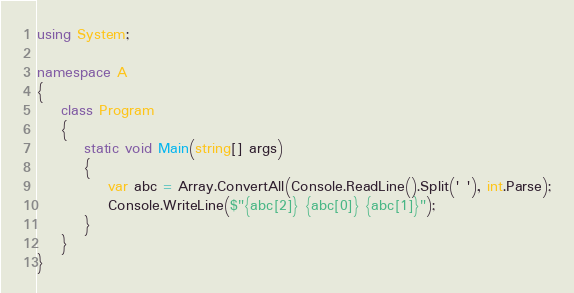Convert code to text. <code><loc_0><loc_0><loc_500><loc_500><_C#_>using System;

namespace A
{
    class Program
    {
        static void Main(string[] args)
        {
            var abc = Array.ConvertAll(Console.ReadLine().Split(' '), int.Parse);
            Console.WriteLine($"{abc[2]} {abc[0]} {abc[1]}");
        }
    }
}
</code> 